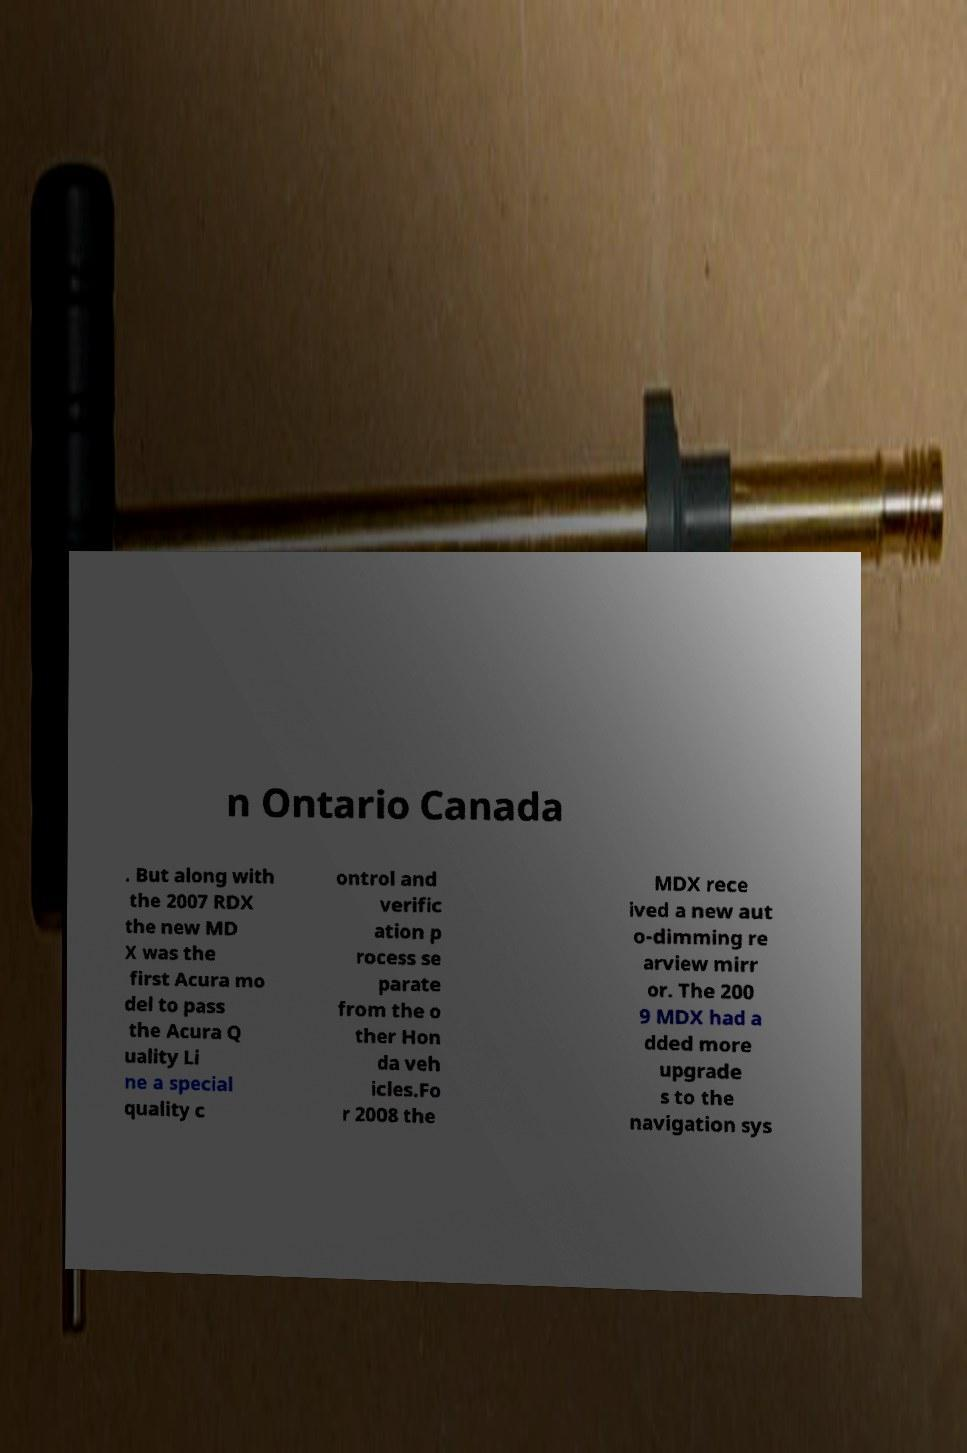Can you accurately transcribe the text from the provided image for me? n Ontario Canada . But along with the 2007 RDX the new MD X was the first Acura mo del to pass the Acura Q uality Li ne a special quality c ontrol and verific ation p rocess se parate from the o ther Hon da veh icles.Fo r 2008 the MDX rece ived a new aut o-dimming re arview mirr or. The 200 9 MDX had a dded more upgrade s to the navigation sys 